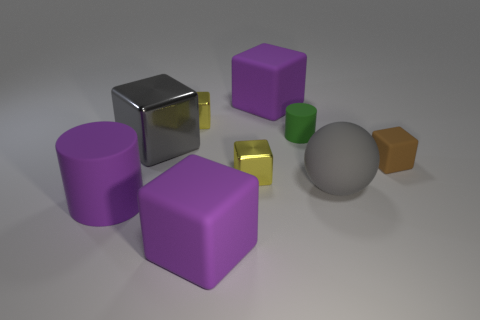Subtract all purple matte blocks. How many blocks are left? 4 Subtract all green cylinders. How many purple cubes are left? 2 Subtract all brown cubes. How many cubes are left? 5 Add 1 large purple matte cylinders. How many objects exist? 10 Subtract all purple cubes. Subtract all cyan balls. How many cubes are left? 4 Add 3 purple cylinders. How many purple cylinders are left? 4 Add 9 big gray shiny spheres. How many big gray shiny spheres exist? 9 Subtract 0 red blocks. How many objects are left? 9 Subtract all cylinders. How many objects are left? 7 Subtract all large purple matte cubes. Subtract all big blocks. How many objects are left? 4 